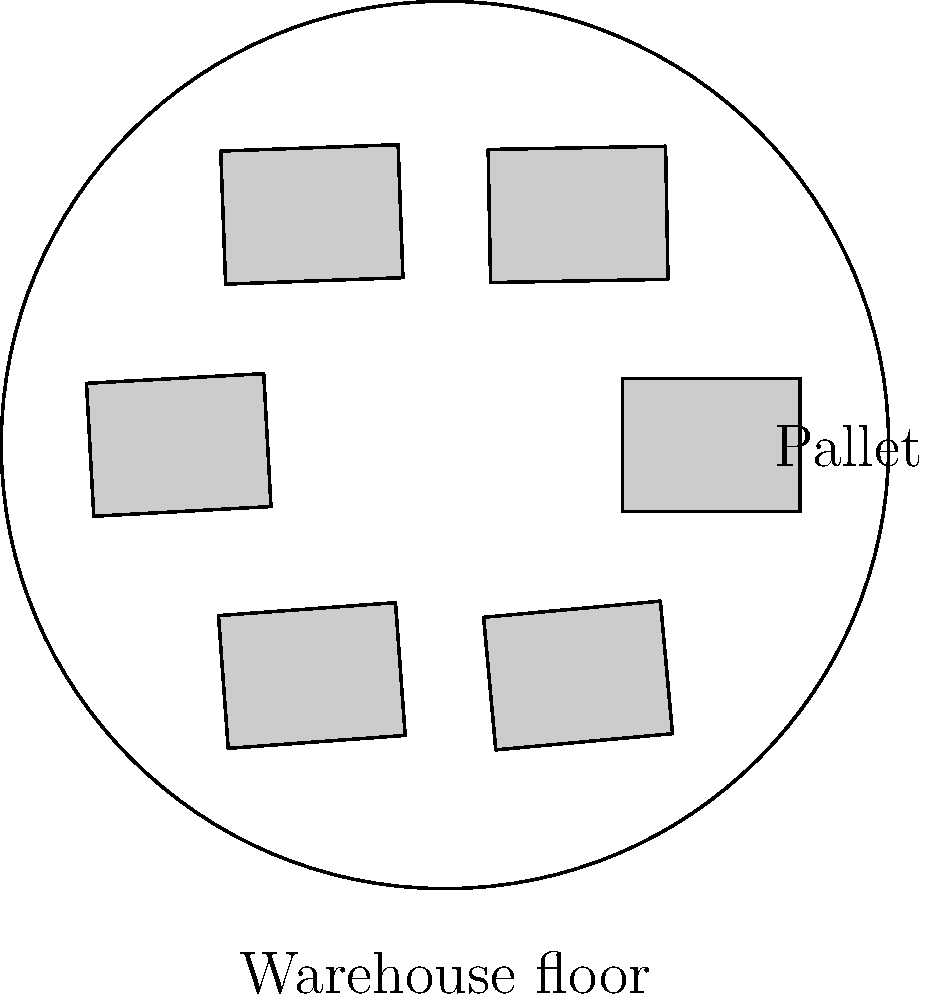As a supplier of raw materials, you're helping a small business owner optimize their warehouse layout. The circular warehouse floor has a radius of 10 meters. Rectangular pallets measuring 4 meters by 3 meters need to be arranged around the perimeter of the floor. What is the maximum number of pallets that can be placed without overlapping, assuming they are positioned tangent to the circle and to each other? To solve this problem, we'll follow these steps:

1) First, we need to determine the angle subtended by each pallet at the center of the circular floor.

2) The chord length of this arc is equal to the width of the pallet (4 meters).

3) We can use the formula for chord length in a circle:
   $$ \text{chord length} = 2r \sin(\theta/2) $$
   where $r$ is the radius and $\theta$ is the central angle in radians.

4) Substituting our values:
   $$ 4 = 2(10) \sin(\theta/2) $$

5) Solving for $\theta$:
   $$ \sin(\theta/2) = \frac{4}{20} = 0.2 $$
   $$ \theta/2 = \arcsin(0.2) $$
   $$ \theta = 2 \arcsin(0.2) \approx 0.4027 \text{ radians} $$

6) The total angle around the circle is $2\pi$ radians.

7) The number of pallets that can fit is:
   $$ \text{Number of pallets} = \frac{2\pi}{\theta} = \frac{2\pi}{0.4027} \approx 15.6 $$

8) Since we can't have a fractional pallet, we round down to 15.

Therefore, the maximum number of pallets that can be placed around the perimeter is 15.
Answer: 15 pallets 